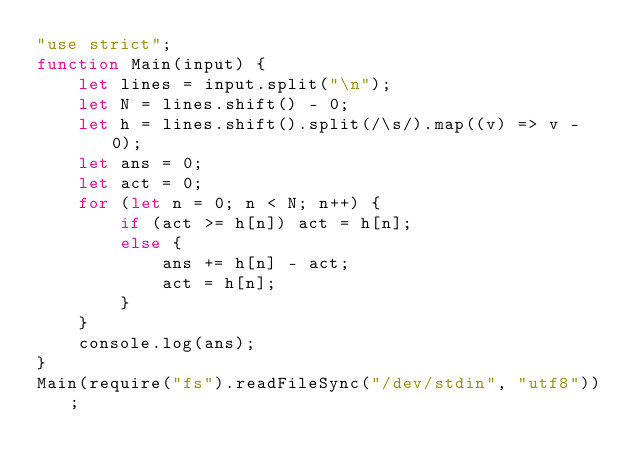<code> <loc_0><loc_0><loc_500><loc_500><_JavaScript_>"use strict";
function Main(input) {
    let lines = input.split("\n");
    let N = lines.shift() - 0;
    let h = lines.shift().split(/\s/).map((v) => v - 0);
    let ans = 0;
    let act = 0;
    for (let n = 0; n < N; n++) {
        if (act >= h[n]) act = h[n];
        else {
            ans += h[n] - act;
            act = h[n];
        }
    }
    console.log(ans);
}
Main(require("fs").readFileSync("/dev/stdin", "utf8"));
</code> 